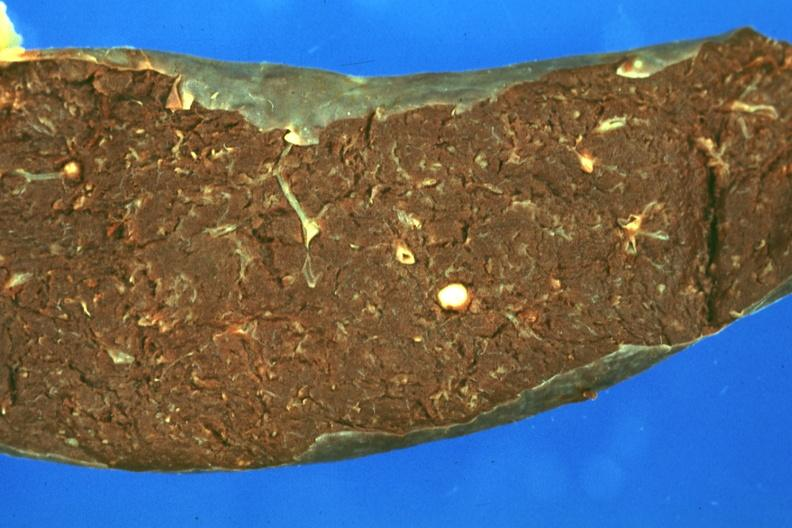s hematologic present?
Answer the question using a single word or phrase. Yes 